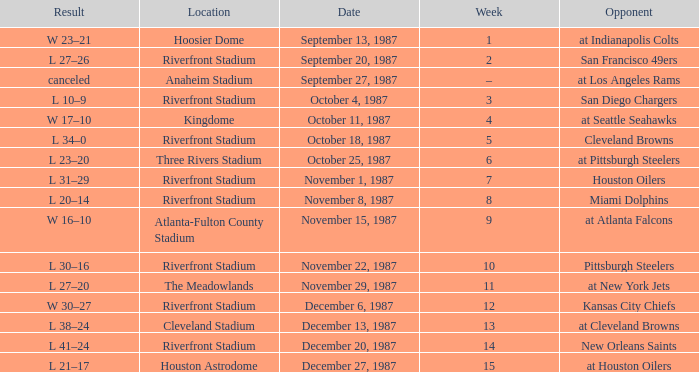What was the outcome of the match at the riverfront stadium following week 8? L 20–14. 